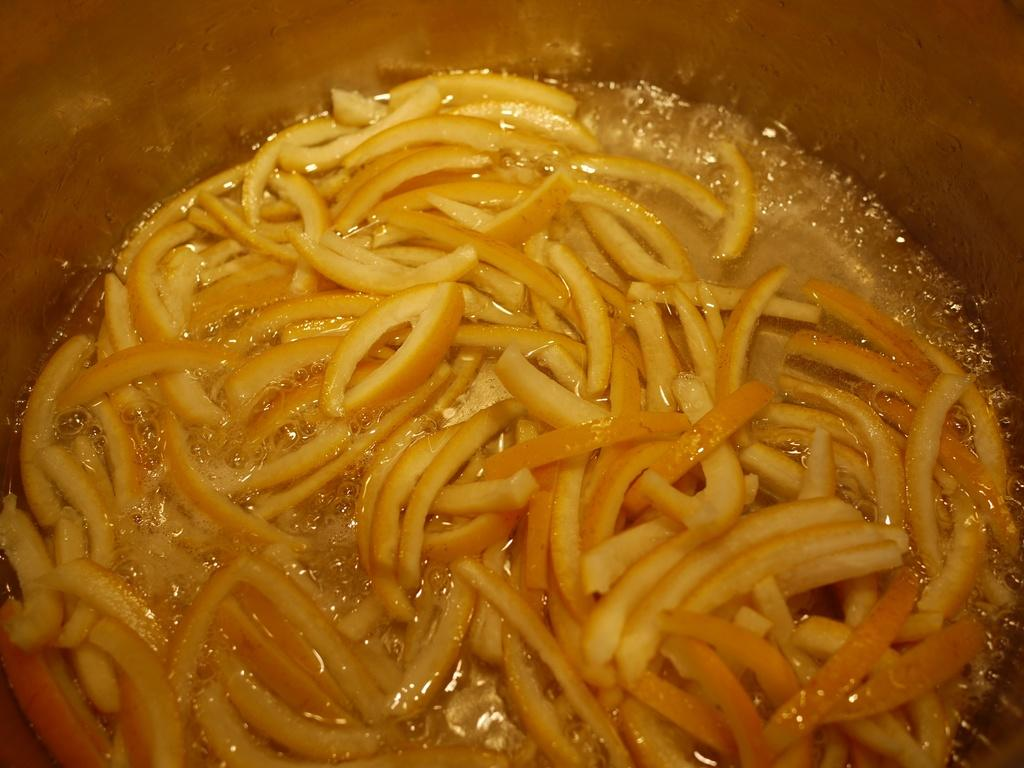What is inside the container in the image? There is a food item in the container. What type of suit is the food item wearing in the image? There is no suit or any clothing present in the image, as it features a food item in a container. 